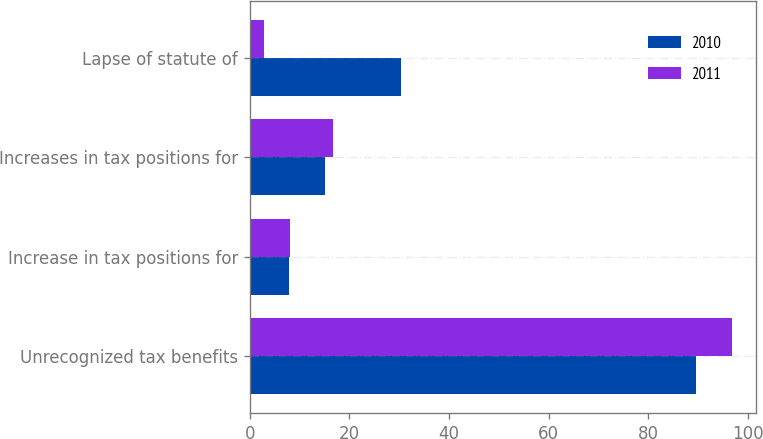Convert chart. <chart><loc_0><loc_0><loc_500><loc_500><stacked_bar_chart><ecel><fcel>Unrecognized tax benefits<fcel>Increase in tax positions for<fcel>Increases in tax positions for<fcel>Lapse of statute of<nl><fcel>2010<fcel>89.5<fcel>7.9<fcel>15.1<fcel>30.3<nl><fcel>2011<fcel>96.8<fcel>8<fcel>16.7<fcel>2.8<nl></chart> 